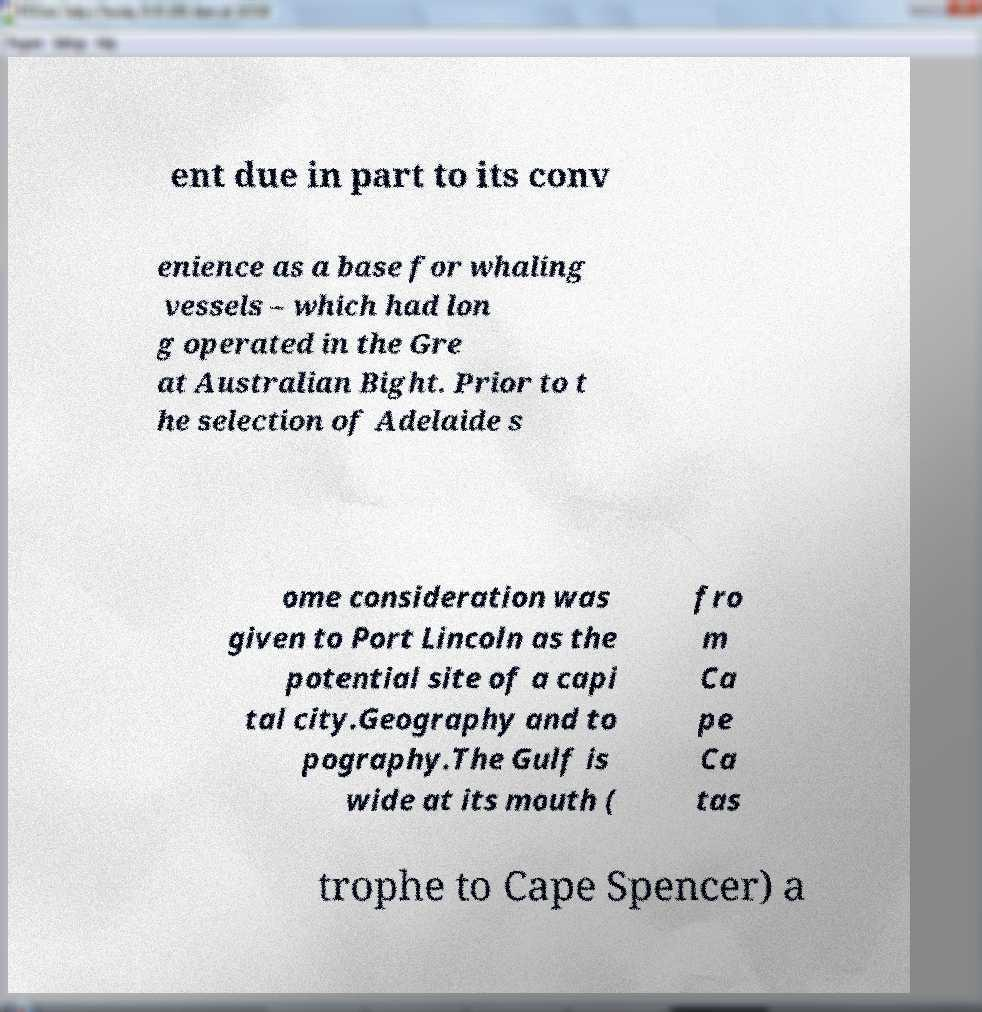Please read and relay the text visible in this image. What does it say? ent due in part to its conv enience as a base for whaling vessels – which had lon g operated in the Gre at Australian Bight. Prior to t he selection of Adelaide s ome consideration was given to Port Lincoln as the potential site of a capi tal city.Geography and to pography.The Gulf is wide at its mouth ( fro m Ca pe Ca tas trophe to Cape Spencer) a 